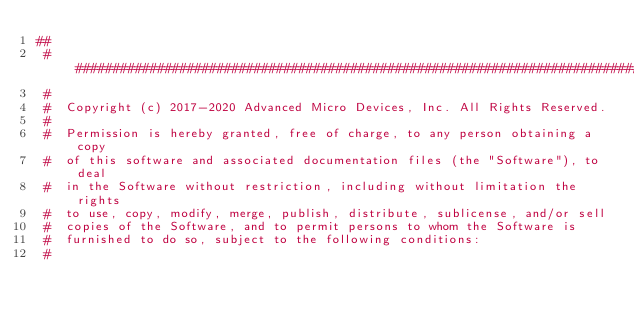<code> <loc_0><loc_0><loc_500><loc_500><_Python_>##
 #######################################################################################################################
 #
 #  Copyright (c) 2017-2020 Advanced Micro Devices, Inc. All Rights Reserved.
 #
 #  Permission is hereby granted, free of charge, to any person obtaining a copy
 #  of this software and associated documentation files (the "Software"), to deal
 #  in the Software without restriction, including without limitation the rights
 #  to use, copy, modify, merge, publish, distribute, sublicense, and/or sell
 #  copies of the Software, and to permit persons to whom the Software is
 #  furnished to do so, subject to the following conditions:
 #</code> 